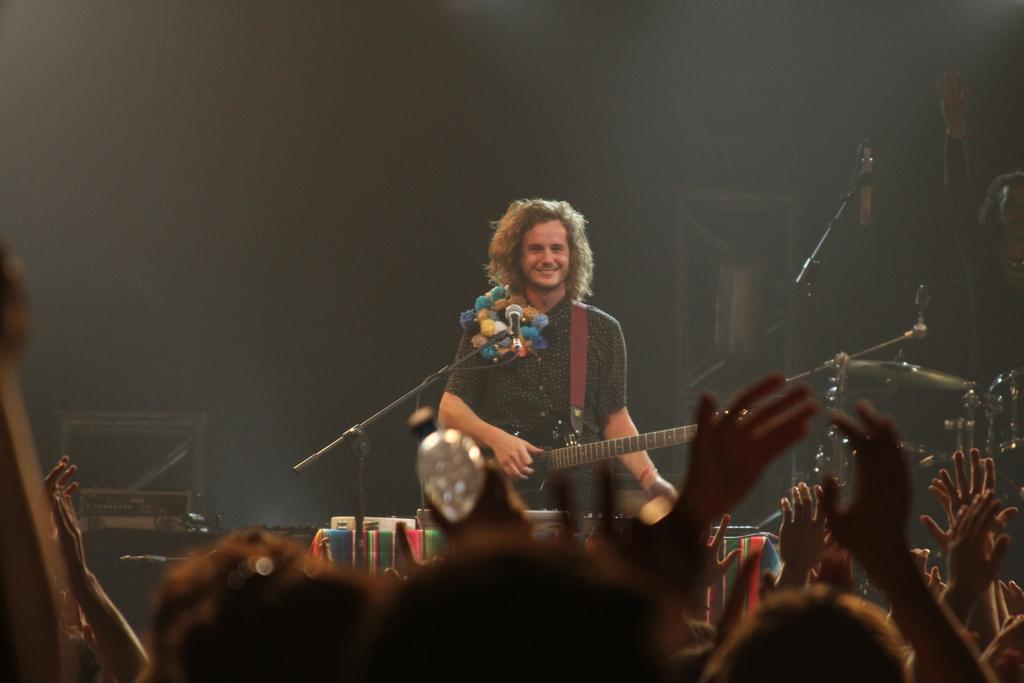What is the person in the image doing? The person is standing in front of a mic and holding a guitar. What might the person be about to do? The person might be about to perform or sing into the mic. Who else is present in the image? There is a group of people observing the person. What type of doctor is treating the person's baseball injury in the image? There is no doctor or baseball injury present in the image. 